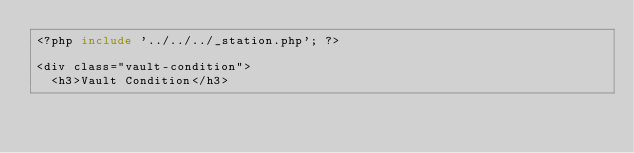<code> <loc_0><loc_0><loc_500><loc_500><_PHP_><?php include '../../../_station.php'; ?>

<div class="vault-condition">
  <h3>Vault Condition</h3></code> 